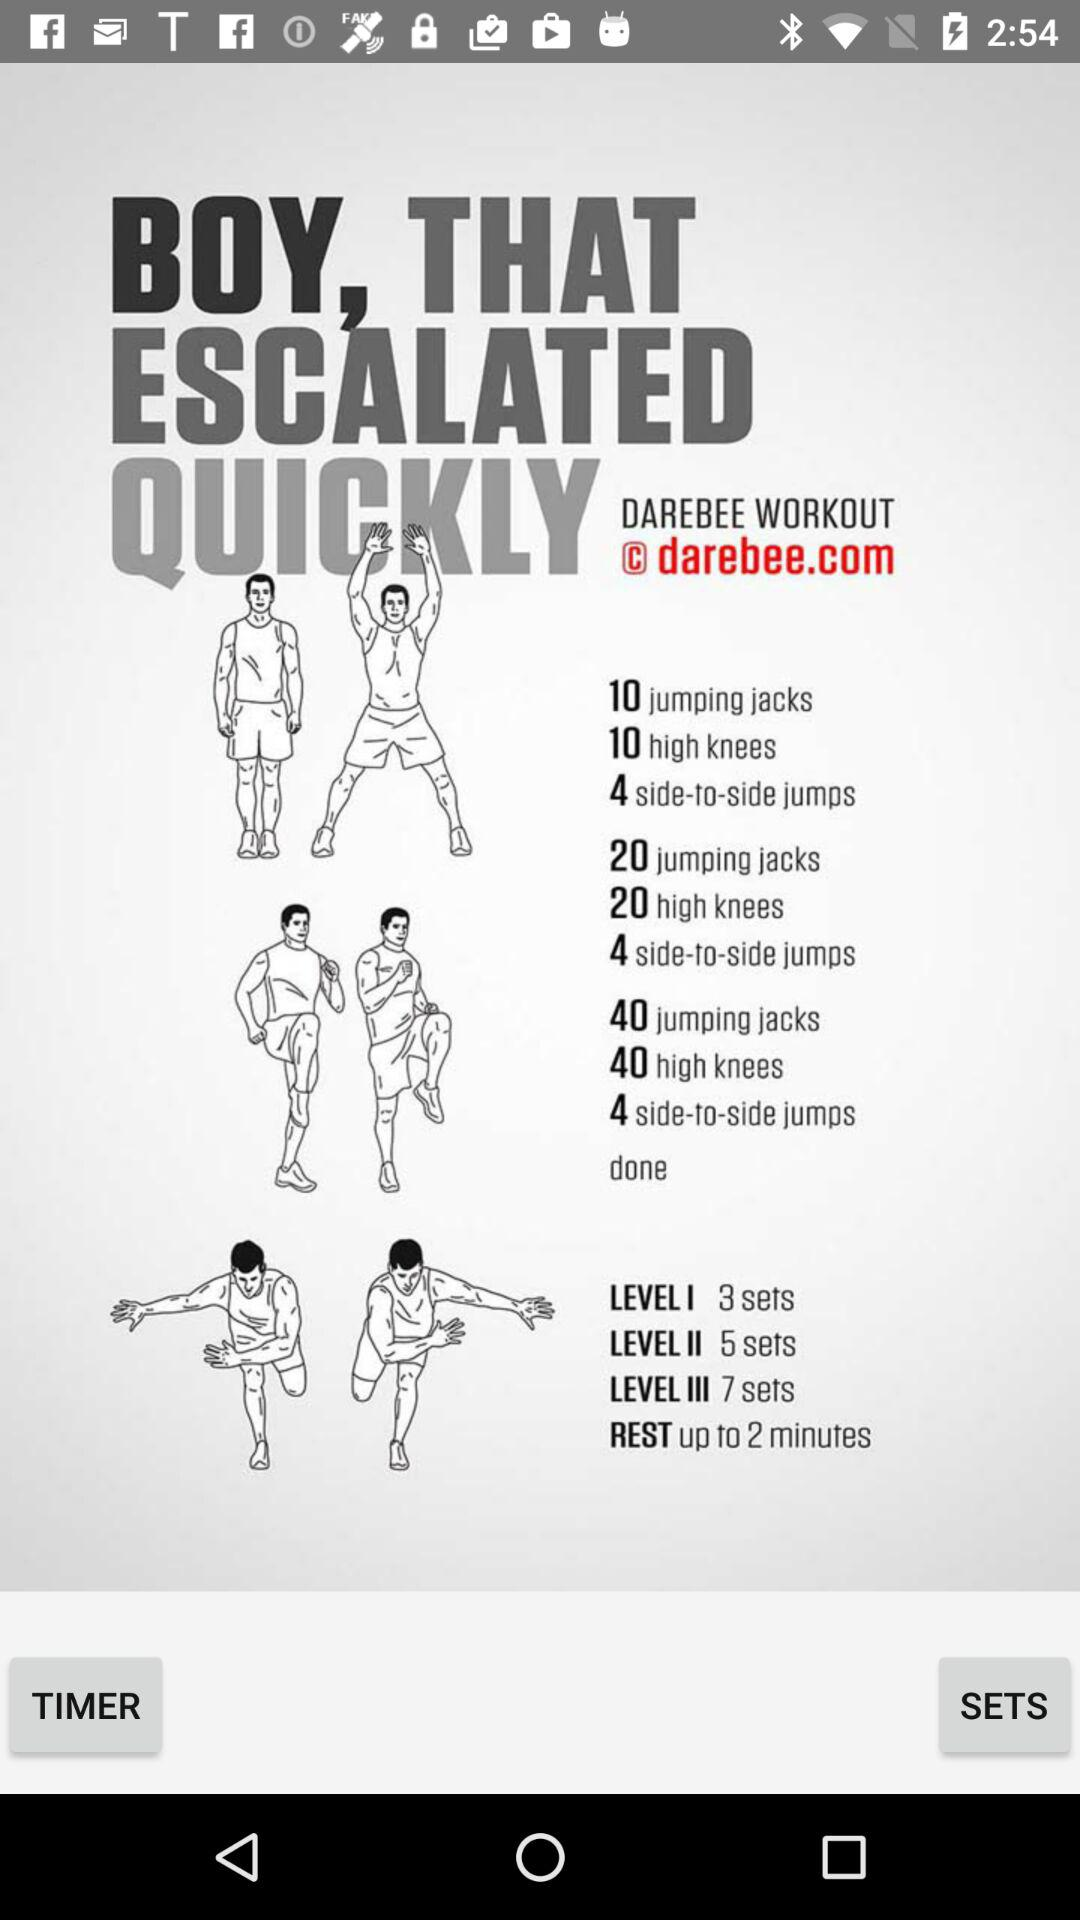What is the number of side-to-side jumps in set 1? The number of side-to-side jumps in set 1 is 4. 